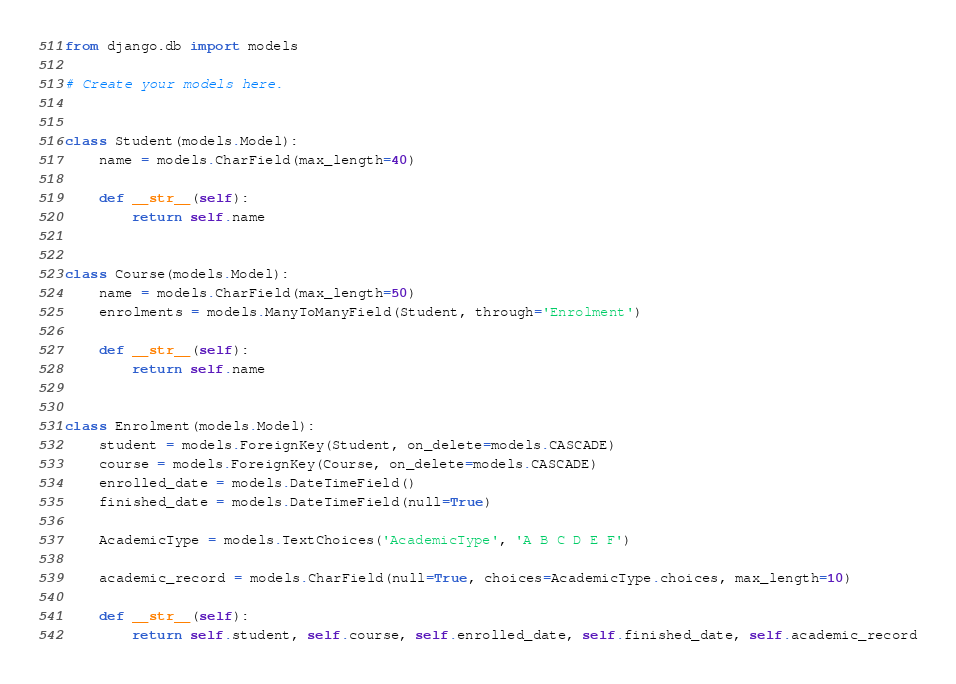<code> <loc_0><loc_0><loc_500><loc_500><_Python_>from django.db import models

# Create your models here.


class Student(models.Model):
    name = models.CharField(max_length=40)

    def __str__(self):
        return self.name


class Course(models.Model):
    name = models.CharField(max_length=50)
    enrolments = models.ManyToManyField(Student, through='Enrolment')

    def __str__(self):
        return self.name


class Enrolment(models.Model):
    student = models.ForeignKey(Student, on_delete=models.CASCADE)
    course = models.ForeignKey(Course, on_delete=models.CASCADE)
    enrolled_date = models.DateTimeField()
    finished_date = models.DateTimeField(null=True)

    AcademicType = models.TextChoices('AcademicType', 'A B C D E F')

    academic_record = models.CharField(null=True, choices=AcademicType.choices, max_length=10)

    def __str__(self):
        return self.student, self.course, self.enrolled_date, self.finished_date, self.academic_record



</code> 